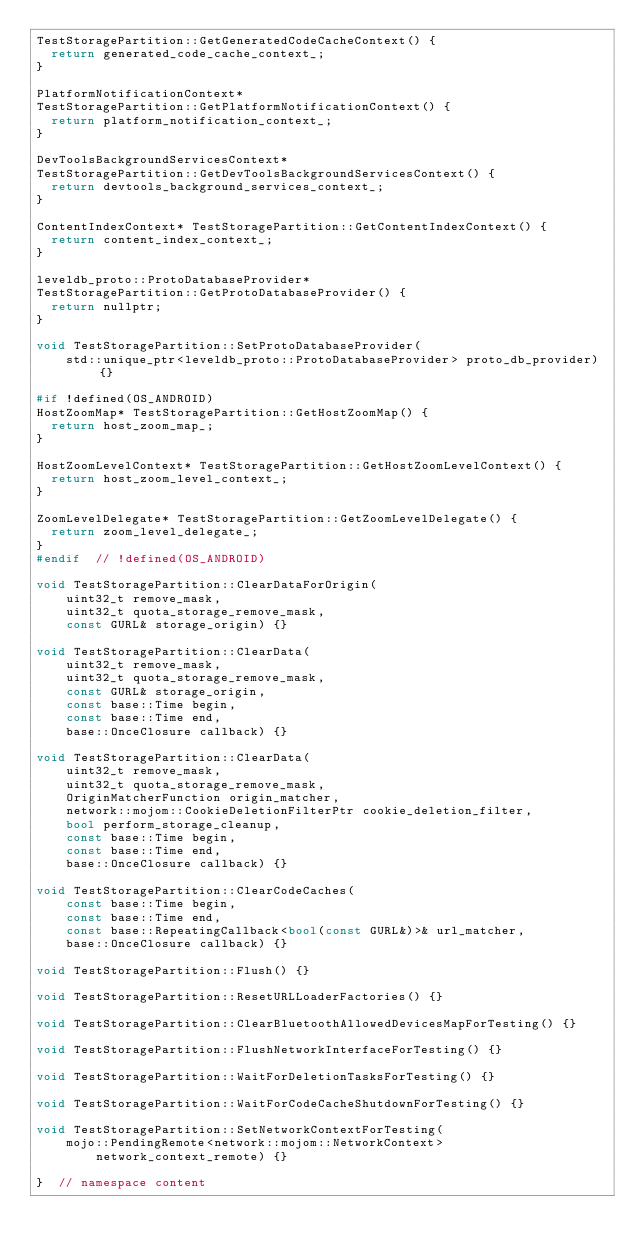Convert code to text. <code><loc_0><loc_0><loc_500><loc_500><_C++_>TestStoragePartition::GetGeneratedCodeCacheContext() {
  return generated_code_cache_context_;
}

PlatformNotificationContext*
TestStoragePartition::GetPlatformNotificationContext() {
  return platform_notification_context_;
}

DevToolsBackgroundServicesContext*
TestStoragePartition::GetDevToolsBackgroundServicesContext() {
  return devtools_background_services_context_;
}

ContentIndexContext* TestStoragePartition::GetContentIndexContext() {
  return content_index_context_;
}

leveldb_proto::ProtoDatabaseProvider*
TestStoragePartition::GetProtoDatabaseProvider() {
  return nullptr;
}

void TestStoragePartition::SetProtoDatabaseProvider(
    std::unique_ptr<leveldb_proto::ProtoDatabaseProvider> proto_db_provider) {}

#if !defined(OS_ANDROID)
HostZoomMap* TestStoragePartition::GetHostZoomMap() {
  return host_zoom_map_;
}

HostZoomLevelContext* TestStoragePartition::GetHostZoomLevelContext() {
  return host_zoom_level_context_;
}

ZoomLevelDelegate* TestStoragePartition::GetZoomLevelDelegate() {
  return zoom_level_delegate_;
}
#endif  // !defined(OS_ANDROID)

void TestStoragePartition::ClearDataForOrigin(
    uint32_t remove_mask,
    uint32_t quota_storage_remove_mask,
    const GURL& storage_origin) {}

void TestStoragePartition::ClearData(
    uint32_t remove_mask,
    uint32_t quota_storage_remove_mask,
    const GURL& storage_origin,
    const base::Time begin,
    const base::Time end,
    base::OnceClosure callback) {}

void TestStoragePartition::ClearData(
    uint32_t remove_mask,
    uint32_t quota_storage_remove_mask,
    OriginMatcherFunction origin_matcher,
    network::mojom::CookieDeletionFilterPtr cookie_deletion_filter,
    bool perform_storage_cleanup,
    const base::Time begin,
    const base::Time end,
    base::OnceClosure callback) {}

void TestStoragePartition::ClearCodeCaches(
    const base::Time begin,
    const base::Time end,
    const base::RepeatingCallback<bool(const GURL&)>& url_matcher,
    base::OnceClosure callback) {}

void TestStoragePartition::Flush() {}

void TestStoragePartition::ResetURLLoaderFactories() {}

void TestStoragePartition::ClearBluetoothAllowedDevicesMapForTesting() {}

void TestStoragePartition::FlushNetworkInterfaceForTesting() {}

void TestStoragePartition::WaitForDeletionTasksForTesting() {}

void TestStoragePartition::WaitForCodeCacheShutdownForTesting() {}

void TestStoragePartition::SetNetworkContextForTesting(
    mojo::PendingRemote<network::mojom::NetworkContext>
        network_context_remote) {}

}  // namespace content
</code> 